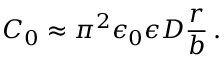Convert formula to latex. <formula><loc_0><loc_0><loc_500><loc_500>C _ { 0 } \approx \pi ^ { 2 } \epsilon _ { 0 } \epsilon D \frac { r } { b } \, .</formula> 